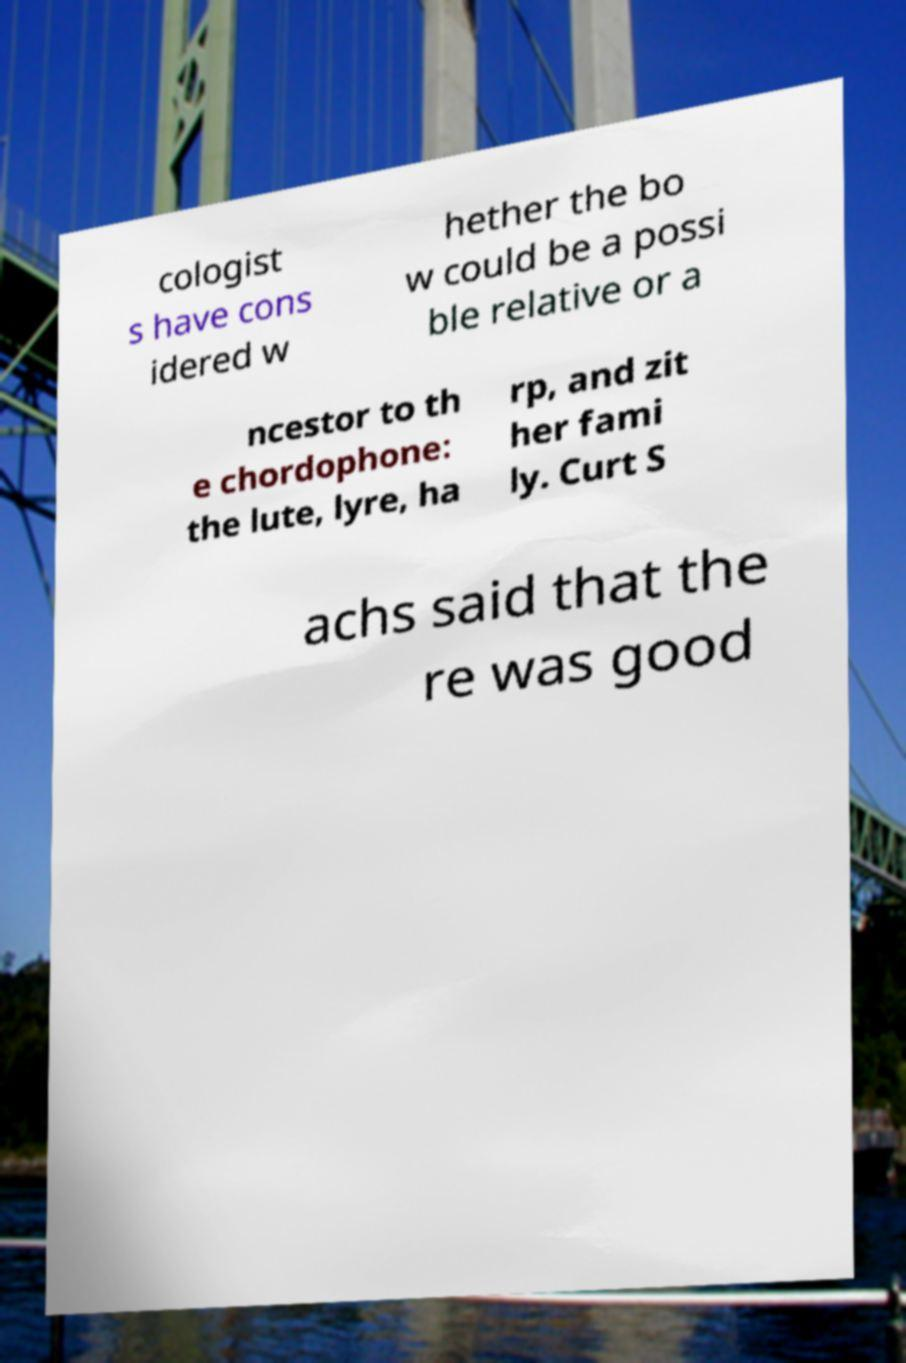I need the written content from this picture converted into text. Can you do that? cologist s have cons idered w hether the bo w could be a possi ble relative or a ncestor to th e chordophone: the lute, lyre, ha rp, and zit her fami ly. Curt S achs said that the re was good 